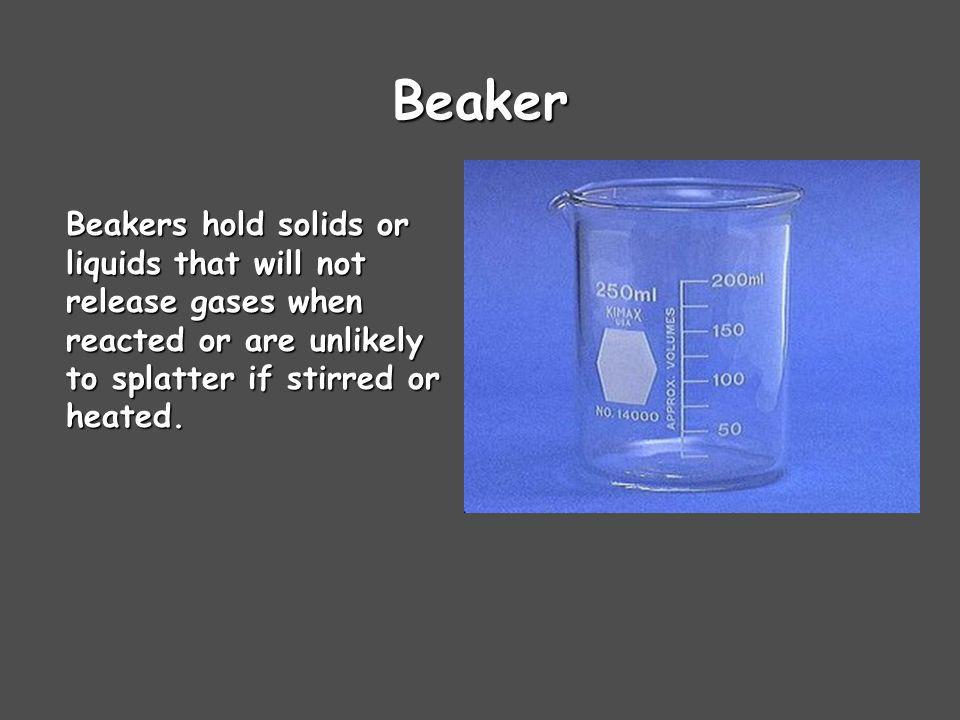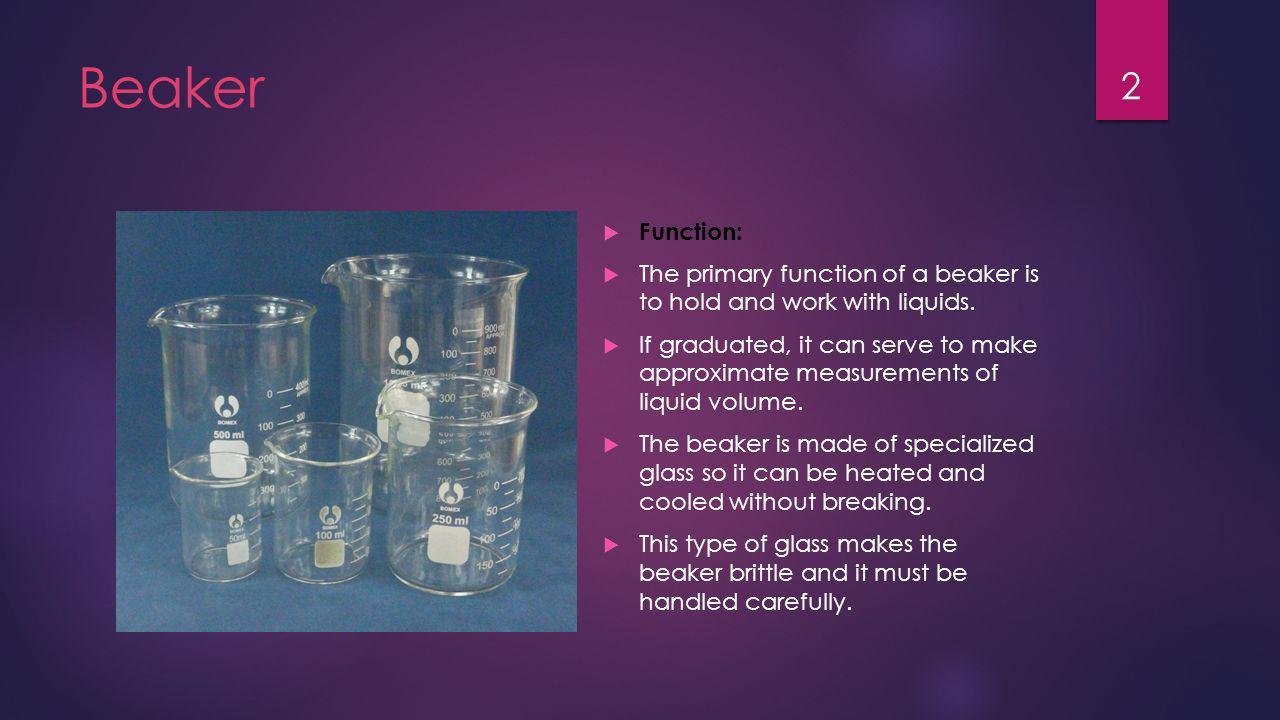The first image is the image on the left, the second image is the image on the right. Assess this claim about the two images: "The right image shows multiple beakers.". Correct or not? Answer yes or no. Yes. The first image is the image on the left, the second image is the image on the right. For the images displayed, is the sentence "There is exactly one empty beaker." factually correct? Answer yes or no. No. 